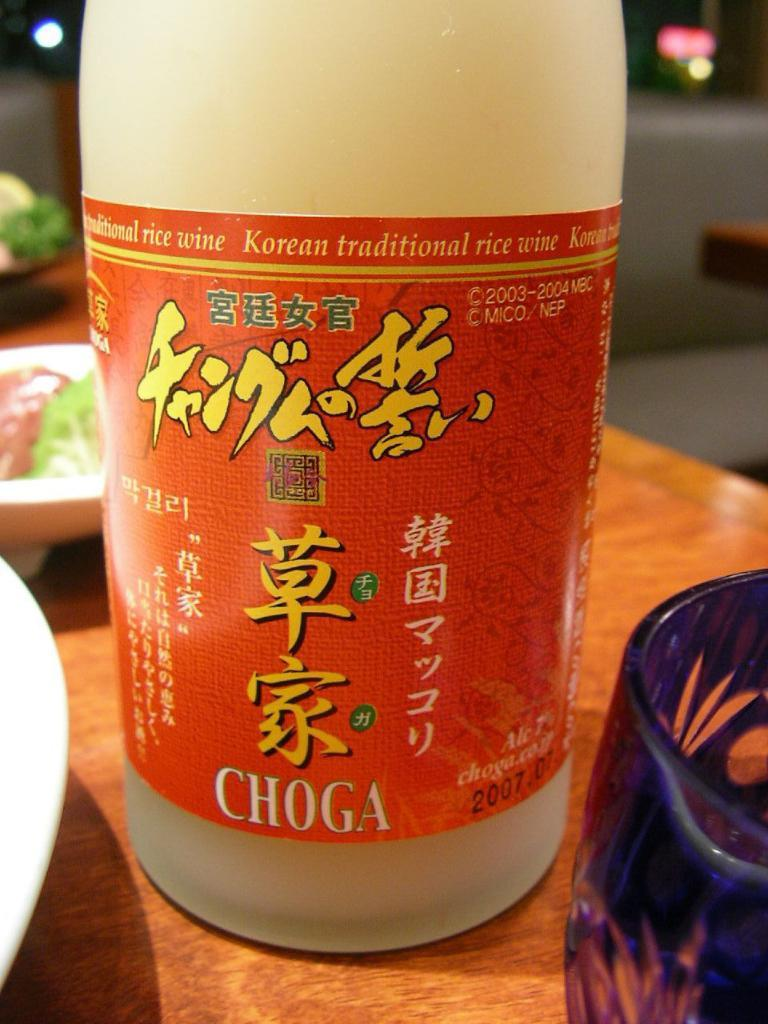<image>
Write a terse but informative summary of the picture. A bottle of Chinese Choga rice wine sitting at a dinner table. 